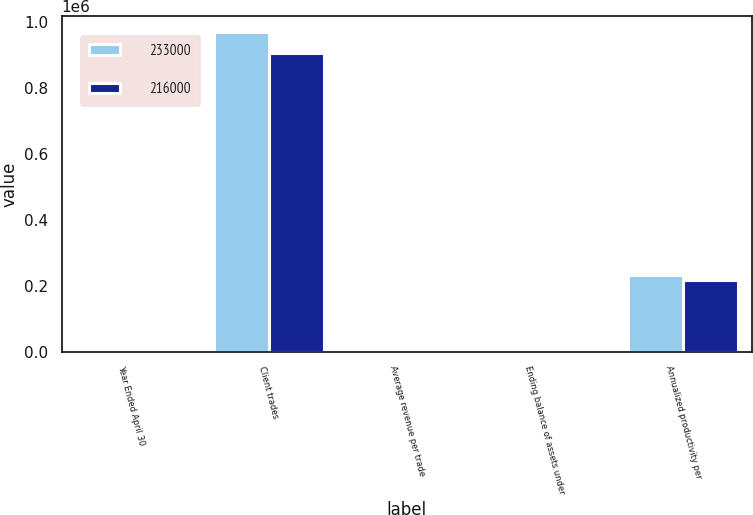Convert chart. <chart><loc_0><loc_0><loc_500><loc_500><stacked_bar_chart><ecel><fcel>Year Ended April 30<fcel>Client trades<fcel>Average revenue per trade<fcel>Ending balance of assets under<fcel>Annualized productivity per<nl><fcel>233000<fcel>2008<fcel>969364<fcel>120.22<fcel>32.1<fcel>233000<nl><fcel>216000<fcel>2007<fcel>907075<fcel>126.54<fcel>33.1<fcel>216000<nl></chart> 